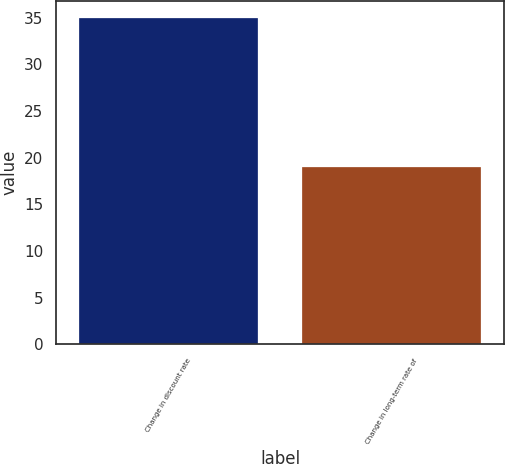<chart> <loc_0><loc_0><loc_500><loc_500><bar_chart><fcel>Change in discount rate<fcel>Change in long-term rate of<nl><fcel>35<fcel>19<nl></chart> 